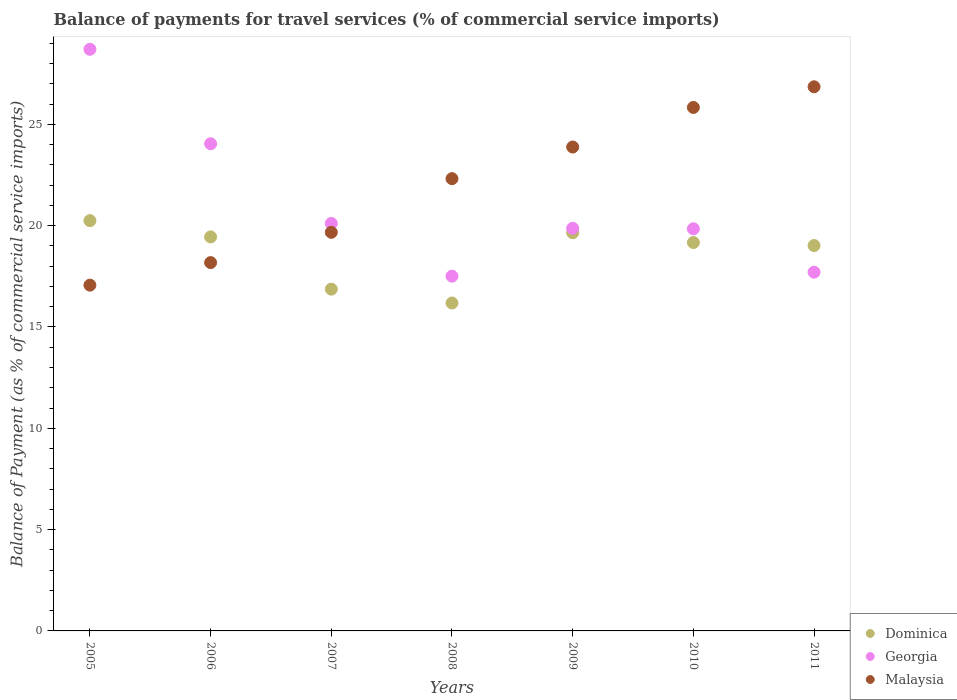What is the balance of payments for travel services in Georgia in 2007?
Provide a short and direct response. 20.11. Across all years, what is the maximum balance of payments for travel services in Georgia?
Make the answer very short. 28.7. Across all years, what is the minimum balance of payments for travel services in Malaysia?
Give a very brief answer. 17.06. What is the total balance of payments for travel services in Dominica in the graph?
Your answer should be compact. 130.57. What is the difference between the balance of payments for travel services in Malaysia in 2006 and that in 2008?
Provide a succinct answer. -4.14. What is the difference between the balance of payments for travel services in Malaysia in 2011 and the balance of payments for travel services in Dominica in 2010?
Ensure brevity in your answer.  7.69. What is the average balance of payments for travel services in Malaysia per year?
Your answer should be very brief. 21.97. In the year 2009, what is the difference between the balance of payments for travel services in Dominica and balance of payments for travel services in Malaysia?
Provide a succinct answer. -4.23. In how many years, is the balance of payments for travel services in Malaysia greater than 5 %?
Offer a very short reply. 7. What is the ratio of the balance of payments for travel services in Malaysia in 2006 to that in 2011?
Ensure brevity in your answer.  0.68. What is the difference between the highest and the second highest balance of payments for travel services in Malaysia?
Offer a terse response. 1.02. What is the difference between the highest and the lowest balance of payments for travel services in Malaysia?
Your answer should be compact. 9.79. In how many years, is the balance of payments for travel services in Malaysia greater than the average balance of payments for travel services in Malaysia taken over all years?
Your response must be concise. 4. Is it the case that in every year, the sum of the balance of payments for travel services in Dominica and balance of payments for travel services in Malaysia  is greater than the balance of payments for travel services in Georgia?
Your answer should be compact. Yes. Is the balance of payments for travel services in Georgia strictly greater than the balance of payments for travel services in Dominica over the years?
Provide a succinct answer. No. What is the difference between two consecutive major ticks on the Y-axis?
Ensure brevity in your answer.  5. Does the graph contain any zero values?
Make the answer very short. No. How many legend labels are there?
Offer a very short reply. 3. What is the title of the graph?
Give a very brief answer. Balance of payments for travel services (% of commercial service imports). Does "Jamaica" appear as one of the legend labels in the graph?
Give a very brief answer. No. What is the label or title of the X-axis?
Keep it short and to the point. Years. What is the label or title of the Y-axis?
Keep it short and to the point. Balance of Payment (as % of commercial service imports). What is the Balance of Payment (as % of commercial service imports) of Dominica in 2005?
Offer a very short reply. 20.25. What is the Balance of Payment (as % of commercial service imports) of Georgia in 2005?
Give a very brief answer. 28.7. What is the Balance of Payment (as % of commercial service imports) of Malaysia in 2005?
Your answer should be compact. 17.06. What is the Balance of Payment (as % of commercial service imports) in Dominica in 2006?
Offer a very short reply. 19.44. What is the Balance of Payment (as % of commercial service imports) of Georgia in 2006?
Give a very brief answer. 24.04. What is the Balance of Payment (as % of commercial service imports) in Malaysia in 2006?
Your answer should be very brief. 18.18. What is the Balance of Payment (as % of commercial service imports) of Dominica in 2007?
Give a very brief answer. 16.87. What is the Balance of Payment (as % of commercial service imports) of Georgia in 2007?
Make the answer very short. 20.11. What is the Balance of Payment (as % of commercial service imports) in Malaysia in 2007?
Your answer should be very brief. 19.67. What is the Balance of Payment (as % of commercial service imports) in Dominica in 2008?
Offer a very short reply. 16.18. What is the Balance of Payment (as % of commercial service imports) in Georgia in 2008?
Offer a terse response. 17.51. What is the Balance of Payment (as % of commercial service imports) in Malaysia in 2008?
Offer a very short reply. 22.32. What is the Balance of Payment (as % of commercial service imports) of Dominica in 2009?
Your answer should be compact. 19.65. What is the Balance of Payment (as % of commercial service imports) in Georgia in 2009?
Your answer should be very brief. 19.87. What is the Balance of Payment (as % of commercial service imports) of Malaysia in 2009?
Give a very brief answer. 23.88. What is the Balance of Payment (as % of commercial service imports) in Dominica in 2010?
Provide a succinct answer. 19.17. What is the Balance of Payment (as % of commercial service imports) in Georgia in 2010?
Ensure brevity in your answer.  19.84. What is the Balance of Payment (as % of commercial service imports) of Malaysia in 2010?
Offer a very short reply. 25.83. What is the Balance of Payment (as % of commercial service imports) in Dominica in 2011?
Your response must be concise. 19.02. What is the Balance of Payment (as % of commercial service imports) of Georgia in 2011?
Your answer should be very brief. 17.7. What is the Balance of Payment (as % of commercial service imports) in Malaysia in 2011?
Offer a very short reply. 26.85. Across all years, what is the maximum Balance of Payment (as % of commercial service imports) of Dominica?
Your answer should be compact. 20.25. Across all years, what is the maximum Balance of Payment (as % of commercial service imports) of Georgia?
Provide a succinct answer. 28.7. Across all years, what is the maximum Balance of Payment (as % of commercial service imports) of Malaysia?
Keep it short and to the point. 26.85. Across all years, what is the minimum Balance of Payment (as % of commercial service imports) of Dominica?
Provide a succinct answer. 16.18. Across all years, what is the minimum Balance of Payment (as % of commercial service imports) of Georgia?
Offer a terse response. 17.51. Across all years, what is the minimum Balance of Payment (as % of commercial service imports) of Malaysia?
Provide a succinct answer. 17.06. What is the total Balance of Payment (as % of commercial service imports) of Dominica in the graph?
Your response must be concise. 130.57. What is the total Balance of Payment (as % of commercial service imports) in Georgia in the graph?
Make the answer very short. 147.77. What is the total Balance of Payment (as % of commercial service imports) of Malaysia in the graph?
Make the answer very short. 153.79. What is the difference between the Balance of Payment (as % of commercial service imports) of Dominica in 2005 and that in 2006?
Your answer should be compact. 0.8. What is the difference between the Balance of Payment (as % of commercial service imports) of Georgia in 2005 and that in 2006?
Your answer should be compact. 4.66. What is the difference between the Balance of Payment (as % of commercial service imports) in Malaysia in 2005 and that in 2006?
Make the answer very short. -1.11. What is the difference between the Balance of Payment (as % of commercial service imports) in Dominica in 2005 and that in 2007?
Your answer should be compact. 3.38. What is the difference between the Balance of Payment (as % of commercial service imports) in Georgia in 2005 and that in 2007?
Offer a terse response. 8.59. What is the difference between the Balance of Payment (as % of commercial service imports) of Malaysia in 2005 and that in 2007?
Make the answer very short. -2.61. What is the difference between the Balance of Payment (as % of commercial service imports) of Dominica in 2005 and that in 2008?
Give a very brief answer. 4.07. What is the difference between the Balance of Payment (as % of commercial service imports) of Georgia in 2005 and that in 2008?
Offer a terse response. 11.2. What is the difference between the Balance of Payment (as % of commercial service imports) of Malaysia in 2005 and that in 2008?
Ensure brevity in your answer.  -5.25. What is the difference between the Balance of Payment (as % of commercial service imports) in Dominica in 2005 and that in 2009?
Keep it short and to the point. 0.6. What is the difference between the Balance of Payment (as % of commercial service imports) of Georgia in 2005 and that in 2009?
Give a very brief answer. 8.84. What is the difference between the Balance of Payment (as % of commercial service imports) of Malaysia in 2005 and that in 2009?
Keep it short and to the point. -6.82. What is the difference between the Balance of Payment (as % of commercial service imports) in Dominica in 2005 and that in 2010?
Your response must be concise. 1.08. What is the difference between the Balance of Payment (as % of commercial service imports) in Georgia in 2005 and that in 2010?
Keep it short and to the point. 8.86. What is the difference between the Balance of Payment (as % of commercial service imports) of Malaysia in 2005 and that in 2010?
Offer a very short reply. -8.77. What is the difference between the Balance of Payment (as % of commercial service imports) of Dominica in 2005 and that in 2011?
Make the answer very short. 1.23. What is the difference between the Balance of Payment (as % of commercial service imports) in Georgia in 2005 and that in 2011?
Make the answer very short. 11. What is the difference between the Balance of Payment (as % of commercial service imports) in Malaysia in 2005 and that in 2011?
Your answer should be very brief. -9.79. What is the difference between the Balance of Payment (as % of commercial service imports) of Dominica in 2006 and that in 2007?
Offer a very short reply. 2.58. What is the difference between the Balance of Payment (as % of commercial service imports) of Georgia in 2006 and that in 2007?
Offer a very short reply. 3.93. What is the difference between the Balance of Payment (as % of commercial service imports) in Malaysia in 2006 and that in 2007?
Ensure brevity in your answer.  -1.49. What is the difference between the Balance of Payment (as % of commercial service imports) in Dominica in 2006 and that in 2008?
Offer a terse response. 3.26. What is the difference between the Balance of Payment (as % of commercial service imports) in Georgia in 2006 and that in 2008?
Provide a succinct answer. 6.53. What is the difference between the Balance of Payment (as % of commercial service imports) in Malaysia in 2006 and that in 2008?
Give a very brief answer. -4.14. What is the difference between the Balance of Payment (as % of commercial service imports) in Dominica in 2006 and that in 2009?
Your answer should be compact. -0.21. What is the difference between the Balance of Payment (as % of commercial service imports) of Georgia in 2006 and that in 2009?
Provide a succinct answer. 4.17. What is the difference between the Balance of Payment (as % of commercial service imports) of Malaysia in 2006 and that in 2009?
Make the answer very short. -5.7. What is the difference between the Balance of Payment (as % of commercial service imports) of Dominica in 2006 and that in 2010?
Offer a very short reply. 0.28. What is the difference between the Balance of Payment (as % of commercial service imports) of Georgia in 2006 and that in 2010?
Provide a short and direct response. 4.2. What is the difference between the Balance of Payment (as % of commercial service imports) of Malaysia in 2006 and that in 2010?
Make the answer very short. -7.66. What is the difference between the Balance of Payment (as % of commercial service imports) in Dominica in 2006 and that in 2011?
Offer a terse response. 0.43. What is the difference between the Balance of Payment (as % of commercial service imports) of Georgia in 2006 and that in 2011?
Make the answer very short. 6.34. What is the difference between the Balance of Payment (as % of commercial service imports) in Malaysia in 2006 and that in 2011?
Make the answer very short. -8.68. What is the difference between the Balance of Payment (as % of commercial service imports) of Dominica in 2007 and that in 2008?
Give a very brief answer. 0.69. What is the difference between the Balance of Payment (as % of commercial service imports) of Georgia in 2007 and that in 2008?
Your response must be concise. 2.6. What is the difference between the Balance of Payment (as % of commercial service imports) in Malaysia in 2007 and that in 2008?
Your answer should be compact. -2.65. What is the difference between the Balance of Payment (as % of commercial service imports) of Dominica in 2007 and that in 2009?
Keep it short and to the point. -2.78. What is the difference between the Balance of Payment (as % of commercial service imports) in Georgia in 2007 and that in 2009?
Ensure brevity in your answer.  0.24. What is the difference between the Balance of Payment (as % of commercial service imports) of Malaysia in 2007 and that in 2009?
Your response must be concise. -4.21. What is the difference between the Balance of Payment (as % of commercial service imports) of Dominica in 2007 and that in 2010?
Your answer should be compact. -2.3. What is the difference between the Balance of Payment (as % of commercial service imports) of Georgia in 2007 and that in 2010?
Your answer should be compact. 0.27. What is the difference between the Balance of Payment (as % of commercial service imports) of Malaysia in 2007 and that in 2010?
Keep it short and to the point. -6.16. What is the difference between the Balance of Payment (as % of commercial service imports) in Dominica in 2007 and that in 2011?
Keep it short and to the point. -2.15. What is the difference between the Balance of Payment (as % of commercial service imports) of Georgia in 2007 and that in 2011?
Offer a very short reply. 2.41. What is the difference between the Balance of Payment (as % of commercial service imports) in Malaysia in 2007 and that in 2011?
Give a very brief answer. -7.18. What is the difference between the Balance of Payment (as % of commercial service imports) in Dominica in 2008 and that in 2009?
Give a very brief answer. -3.47. What is the difference between the Balance of Payment (as % of commercial service imports) in Georgia in 2008 and that in 2009?
Provide a succinct answer. -2.36. What is the difference between the Balance of Payment (as % of commercial service imports) in Malaysia in 2008 and that in 2009?
Your response must be concise. -1.56. What is the difference between the Balance of Payment (as % of commercial service imports) in Dominica in 2008 and that in 2010?
Your answer should be very brief. -2.99. What is the difference between the Balance of Payment (as % of commercial service imports) in Georgia in 2008 and that in 2010?
Offer a terse response. -2.34. What is the difference between the Balance of Payment (as % of commercial service imports) in Malaysia in 2008 and that in 2010?
Give a very brief answer. -3.51. What is the difference between the Balance of Payment (as % of commercial service imports) in Dominica in 2008 and that in 2011?
Your response must be concise. -2.84. What is the difference between the Balance of Payment (as % of commercial service imports) in Georgia in 2008 and that in 2011?
Offer a very short reply. -0.2. What is the difference between the Balance of Payment (as % of commercial service imports) in Malaysia in 2008 and that in 2011?
Your response must be concise. -4.53. What is the difference between the Balance of Payment (as % of commercial service imports) of Dominica in 2009 and that in 2010?
Offer a terse response. 0.48. What is the difference between the Balance of Payment (as % of commercial service imports) in Georgia in 2009 and that in 2010?
Provide a succinct answer. 0.02. What is the difference between the Balance of Payment (as % of commercial service imports) in Malaysia in 2009 and that in 2010?
Offer a very short reply. -1.95. What is the difference between the Balance of Payment (as % of commercial service imports) of Dominica in 2009 and that in 2011?
Offer a terse response. 0.63. What is the difference between the Balance of Payment (as % of commercial service imports) in Georgia in 2009 and that in 2011?
Your answer should be compact. 2.16. What is the difference between the Balance of Payment (as % of commercial service imports) of Malaysia in 2009 and that in 2011?
Keep it short and to the point. -2.97. What is the difference between the Balance of Payment (as % of commercial service imports) of Dominica in 2010 and that in 2011?
Provide a succinct answer. 0.15. What is the difference between the Balance of Payment (as % of commercial service imports) in Georgia in 2010 and that in 2011?
Provide a short and direct response. 2.14. What is the difference between the Balance of Payment (as % of commercial service imports) in Malaysia in 2010 and that in 2011?
Provide a succinct answer. -1.02. What is the difference between the Balance of Payment (as % of commercial service imports) of Dominica in 2005 and the Balance of Payment (as % of commercial service imports) of Georgia in 2006?
Offer a very short reply. -3.79. What is the difference between the Balance of Payment (as % of commercial service imports) of Dominica in 2005 and the Balance of Payment (as % of commercial service imports) of Malaysia in 2006?
Keep it short and to the point. 2.07. What is the difference between the Balance of Payment (as % of commercial service imports) in Georgia in 2005 and the Balance of Payment (as % of commercial service imports) in Malaysia in 2006?
Make the answer very short. 10.53. What is the difference between the Balance of Payment (as % of commercial service imports) in Dominica in 2005 and the Balance of Payment (as % of commercial service imports) in Georgia in 2007?
Provide a short and direct response. 0.14. What is the difference between the Balance of Payment (as % of commercial service imports) of Dominica in 2005 and the Balance of Payment (as % of commercial service imports) of Malaysia in 2007?
Your answer should be very brief. 0.58. What is the difference between the Balance of Payment (as % of commercial service imports) of Georgia in 2005 and the Balance of Payment (as % of commercial service imports) of Malaysia in 2007?
Make the answer very short. 9.03. What is the difference between the Balance of Payment (as % of commercial service imports) of Dominica in 2005 and the Balance of Payment (as % of commercial service imports) of Georgia in 2008?
Provide a short and direct response. 2.74. What is the difference between the Balance of Payment (as % of commercial service imports) in Dominica in 2005 and the Balance of Payment (as % of commercial service imports) in Malaysia in 2008?
Keep it short and to the point. -2.07. What is the difference between the Balance of Payment (as % of commercial service imports) of Georgia in 2005 and the Balance of Payment (as % of commercial service imports) of Malaysia in 2008?
Give a very brief answer. 6.38. What is the difference between the Balance of Payment (as % of commercial service imports) of Dominica in 2005 and the Balance of Payment (as % of commercial service imports) of Georgia in 2009?
Offer a very short reply. 0.38. What is the difference between the Balance of Payment (as % of commercial service imports) of Dominica in 2005 and the Balance of Payment (as % of commercial service imports) of Malaysia in 2009?
Make the answer very short. -3.63. What is the difference between the Balance of Payment (as % of commercial service imports) in Georgia in 2005 and the Balance of Payment (as % of commercial service imports) in Malaysia in 2009?
Your answer should be compact. 4.82. What is the difference between the Balance of Payment (as % of commercial service imports) of Dominica in 2005 and the Balance of Payment (as % of commercial service imports) of Georgia in 2010?
Your answer should be very brief. 0.4. What is the difference between the Balance of Payment (as % of commercial service imports) in Dominica in 2005 and the Balance of Payment (as % of commercial service imports) in Malaysia in 2010?
Your answer should be compact. -5.59. What is the difference between the Balance of Payment (as % of commercial service imports) of Georgia in 2005 and the Balance of Payment (as % of commercial service imports) of Malaysia in 2010?
Your answer should be compact. 2.87. What is the difference between the Balance of Payment (as % of commercial service imports) of Dominica in 2005 and the Balance of Payment (as % of commercial service imports) of Georgia in 2011?
Offer a very short reply. 2.54. What is the difference between the Balance of Payment (as % of commercial service imports) of Dominica in 2005 and the Balance of Payment (as % of commercial service imports) of Malaysia in 2011?
Offer a terse response. -6.61. What is the difference between the Balance of Payment (as % of commercial service imports) in Georgia in 2005 and the Balance of Payment (as % of commercial service imports) in Malaysia in 2011?
Your answer should be very brief. 1.85. What is the difference between the Balance of Payment (as % of commercial service imports) in Dominica in 2006 and the Balance of Payment (as % of commercial service imports) in Georgia in 2007?
Ensure brevity in your answer.  -0.66. What is the difference between the Balance of Payment (as % of commercial service imports) in Dominica in 2006 and the Balance of Payment (as % of commercial service imports) in Malaysia in 2007?
Give a very brief answer. -0.23. What is the difference between the Balance of Payment (as % of commercial service imports) of Georgia in 2006 and the Balance of Payment (as % of commercial service imports) of Malaysia in 2007?
Make the answer very short. 4.37. What is the difference between the Balance of Payment (as % of commercial service imports) in Dominica in 2006 and the Balance of Payment (as % of commercial service imports) in Georgia in 2008?
Your response must be concise. 1.94. What is the difference between the Balance of Payment (as % of commercial service imports) in Dominica in 2006 and the Balance of Payment (as % of commercial service imports) in Malaysia in 2008?
Your answer should be very brief. -2.87. What is the difference between the Balance of Payment (as % of commercial service imports) in Georgia in 2006 and the Balance of Payment (as % of commercial service imports) in Malaysia in 2008?
Provide a short and direct response. 1.72. What is the difference between the Balance of Payment (as % of commercial service imports) of Dominica in 2006 and the Balance of Payment (as % of commercial service imports) of Georgia in 2009?
Give a very brief answer. -0.42. What is the difference between the Balance of Payment (as % of commercial service imports) in Dominica in 2006 and the Balance of Payment (as % of commercial service imports) in Malaysia in 2009?
Your answer should be very brief. -4.43. What is the difference between the Balance of Payment (as % of commercial service imports) in Georgia in 2006 and the Balance of Payment (as % of commercial service imports) in Malaysia in 2009?
Provide a short and direct response. 0.16. What is the difference between the Balance of Payment (as % of commercial service imports) in Dominica in 2006 and the Balance of Payment (as % of commercial service imports) in Georgia in 2010?
Your answer should be compact. -0.4. What is the difference between the Balance of Payment (as % of commercial service imports) in Dominica in 2006 and the Balance of Payment (as % of commercial service imports) in Malaysia in 2010?
Your response must be concise. -6.39. What is the difference between the Balance of Payment (as % of commercial service imports) of Georgia in 2006 and the Balance of Payment (as % of commercial service imports) of Malaysia in 2010?
Your answer should be compact. -1.79. What is the difference between the Balance of Payment (as % of commercial service imports) of Dominica in 2006 and the Balance of Payment (as % of commercial service imports) of Georgia in 2011?
Give a very brief answer. 1.74. What is the difference between the Balance of Payment (as % of commercial service imports) of Dominica in 2006 and the Balance of Payment (as % of commercial service imports) of Malaysia in 2011?
Provide a succinct answer. -7.41. What is the difference between the Balance of Payment (as % of commercial service imports) of Georgia in 2006 and the Balance of Payment (as % of commercial service imports) of Malaysia in 2011?
Make the answer very short. -2.81. What is the difference between the Balance of Payment (as % of commercial service imports) in Dominica in 2007 and the Balance of Payment (as % of commercial service imports) in Georgia in 2008?
Provide a succinct answer. -0.64. What is the difference between the Balance of Payment (as % of commercial service imports) of Dominica in 2007 and the Balance of Payment (as % of commercial service imports) of Malaysia in 2008?
Provide a short and direct response. -5.45. What is the difference between the Balance of Payment (as % of commercial service imports) in Georgia in 2007 and the Balance of Payment (as % of commercial service imports) in Malaysia in 2008?
Give a very brief answer. -2.21. What is the difference between the Balance of Payment (as % of commercial service imports) in Dominica in 2007 and the Balance of Payment (as % of commercial service imports) in Georgia in 2009?
Provide a succinct answer. -3. What is the difference between the Balance of Payment (as % of commercial service imports) in Dominica in 2007 and the Balance of Payment (as % of commercial service imports) in Malaysia in 2009?
Offer a very short reply. -7.01. What is the difference between the Balance of Payment (as % of commercial service imports) of Georgia in 2007 and the Balance of Payment (as % of commercial service imports) of Malaysia in 2009?
Your response must be concise. -3.77. What is the difference between the Balance of Payment (as % of commercial service imports) in Dominica in 2007 and the Balance of Payment (as % of commercial service imports) in Georgia in 2010?
Offer a terse response. -2.98. What is the difference between the Balance of Payment (as % of commercial service imports) in Dominica in 2007 and the Balance of Payment (as % of commercial service imports) in Malaysia in 2010?
Keep it short and to the point. -8.97. What is the difference between the Balance of Payment (as % of commercial service imports) in Georgia in 2007 and the Balance of Payment (as % of commercial service imports) in Malaysia in 2010?
Provide a succinct answer. -5.72. What is the difference between the Balance of Payment (as % of commercial service imports) in Dominica in 2007 and the Balance of Payment (as % of commercial service imports) in Georgia in 2011?
Keep it short and to the point. -0.84. What is the difference between the Balance of Payment (as % of commercial service imports) in Dominica in 2007 and the Balance of Payment (as % of commercial service imports) in Malaysia in 2011?
Make the answer very short. -9.99. What is the difference between the Balance of Payment (as % of commercial service imports) of Georgia in 2007 and the Balance of Payment (as % of commercial service imports) of Malaysia in 2011?
Your response must be concise. -6.74. What is the difference between the Balance of Payment (as % of commercial service imports) of Dominica in 2008 and the Balance of Payment (as % of commercial service imports) of Georgia in 2009?
Offer a terse response. -3.69. What is the difference between the Balance of Payment (as % of commercial service imports) in Dominica in 2008 and the Balance of Payment (as % of commercial service imports) in Malaysia in 2009?
Ensure brevity in your answer.  -7.7. What is the difference between the Balance of Payment (as % of commercial service imports) of Georgia in 2008 and the Balance of Payment (as % of commercial service imports) of Malaysia in 2009?
Keep it short and to the point. -6.37. What is the difference between the Balance of Payment (as % of commercial service imports) in Dominica in 2008 and the Balance of Payment (as % of commercial service imports) in Georgia in 2010?
Provide a short and direct response. -3.66. What is the difference between the Balance of Payment (as % of commercial service imports) in Dominica in 2008 and the Balance of Payment (as % of commercial service imports) in Malaysia in 2010?
Ensure brevity in your answer.  -9.65. What is the difference between the Balance of Payment (as % of commercial service imports) in Georgia in 2008 and the Balance of Payment (as % of commercial service imports) in Malaysia in 2010?
Give a very brief answer. -8.32. What is the difference between the Balance of Payment (as % of commercial service imports) of Dominica in 2008 and the Balance of Payment (as % of commercial service imports) of Georgia in 2011?
Make the answer very short. -1.52. What is the difference between the Balance of Payment (as % of commercial service imports) of Dominica in 2008 and the Balance of Payment (as % of commercial service imports) of Malaysia in 2011?
Keep it short and to the point. -10.67. What is the difference between the Balance of Payment (as % of commercial service imports) of Georgia in 2008 and the Balance of Payment (as % of commercial service imports) of Malaysia in 2011?
Your response must be concise. -9.34. What is the difference between the Balance of Payment (as % of commercial service imports) of Dominica in 2009 and the Balance of Payment (as % of commercial service imports) of Georgia in 2010?
Offer a terse response. -0.19. What is the difference between the Balance of Payment (as % of commercial service imports) in Dominica in 2009 and the Balance of Payment (as % of commercial service imports) in Malaysia in 2010?
Make the answer very short. -6.18. What is the difference between the Balance of Payment (as % of commercial service imports) in Georgia in 2009 and the Balance of Payment (as % of commercial service imports) in Malaysia in 2010?
Provide a short and direct response. -5.96. What is the difference between the Balance of Payment (as % of commercial service imports) in Dominica in 2009 and the Balance of Payment (as % of commercial service imports) in Georgia in 2011?
Your answer should be very brief. 1.95. What is the difference between the Balance of Payment (as % of commercial service imports) of Dominica in 2009 and the Balance of Payment (as % of commercial service imports) of Malaysia in 2011?
Give a very brief answer. -7.2. What is the difference between the Balance of Payment (as % of commercial service imports) in Georgia in 2009 and the Balance of Payment (as % of commercial service imports) in Malaysia in 2011?
Your response must be concise. -6.98. What is the difference between the Balance of Payment (as % of commercial service imports) in Dominica in 2010 and the Balance of Payment (as % of commercial service imports) in Georgia in 2011?
Offer a terse response. 1.46. What is the difference between the Balance of Payment (as % of commercial service imports) in Dominica in 2010 and the Balance of Payment (as % of commercial service imports) in Malaysia in 2011?
Offer a terse response. -7.69. What is the difference between the Balance of Payment (as % of commercial service imports) of Georgia in 2010 and the Balance of Payment (as % of commercial service imports) of Malaysia in 2011?
Give a very brief answer. -7.01. What is the average Balance of Payment (as % of commercial service imports) in Dominica per year?
Ensure brevity in your answer.  18.65. What is the average Balance of Payment (as % of commercial service imports) of Georgia per year?
Provide a short and direct response. 21.11. What is the average Balance of Payment (as % of commercial service imports) of Malaysia per year?
Provide a succinct answer. 21.97. In the year 2005, what is the difference between the Balance of Payment (as % of commercial service imports) in Dominica and Balance of Payment (as % of commercial service imports) in Georgia?
Your answer should be very brief. -8.46. In the year 2005, what is the difference between the Balance of Payment (as % of commercial service imports) of Dominica and Balance of Payment (as % of commercial service imports) of Malaysia?
Give a very brief answer. 3.18. In the year 2005, what is the difference between the Balance of Payment (as % of commercial service imports) in Georgia and Balance of Payment (as % of commercial service imports) in Malaysia?
Offer a very short reply. 11.64. In the year 2006, what is the difference between the Balance of Payment (as % of commercial service imports) in Dominica and Balance of Payment (as % of commercial service imports) in Georgia?
Offer a terse response. -4.6. In the year 2006, what is the difference between the Balance of Payment (as % of commercial service imports) in Dominica and Balance of Payment (as % of commercial service imports) in Malaysia?
Your answer should be very brief. 1.27. In the year 2006, what is the difference between the Balance of Payment (as % of commercial service imports) of Georgia and Balance of Payment (as % of commercial service imports) of Malaysia?
Your response must be concise. 5.86. In the year 2007, what is the difference between the Balance of Payment (as % of commercial service imports) of Dominica and Balance of Payment (as % of commercial service imports) of Georgia?
Provide a short and direct response. -3.24. In the year 2007, what is the difference between the Balance of Payment (as % of commercial service imports) of Dominica and Balance of Payment (as % of commercial service imports) of Malaysia?
Ensure brevity in your answer.  -2.8. In the year 2007, what is the difference between the Balance of Payment (as % of commercial service imports) of Georgia and Balance of Payment (as % of commercial service imports) of Malaysia?
Offer a very short reply. 0.44. In the year 2008, what is the difference between the Balance of Payment (as % of commercial service imports) in Dominica and Balance of Payment (as % of commercial service imports) in Georgia?
Offer a very short reply. -1.33. In the year 2008, what is the difference between the Balance of Payment (as % of commercial service imports) of Dominica and Balance of Payment (as % of commercial service imports) of Malaysia?
Offer a very short reply. -6.14. In the year 2008, what is the difference between the Balance of Payment (as % of commercial service imports) in Georgia and Balance of Payment (as % of commercial service imports) in Malaysia?
Your answer should be compact. -4.81. In the year 2009, what is the difference between the Balance of Payment (as % of commercial service imports) of Dominica and Balance of Payment (as % of commercial service imports) of Georgia?
Give a very brief answer. -0.22. In the year 2009, what is the difference between the Balance of Payment (as % of commercial service imports) of Dominica and Balance of Payment (as % of commercial service imports) of Malaysia?
Offer a very short reply. -4.23. In the year 2009, what is the difference between the Balance of Payment (as % of commercial service imports) in Georgia and Balance of Payment (as % of commercial service imports) in Malaysia?
Offer a very short reply. -4.01. In the year 2010, what is the difference between the Balance of Payment (as % of commercial service imports) of Dominica and Balance of Payment (as % of commercial service imports) of Georgia?
Offer a terse response. -0.68. In the year 2010, what is the difference between the Balance of Payment (as % of commercial service imports) in Dominica and Balance of Payment (as % of commercial service imports) in Malaysia?
Offer a terse response. -6.67. In the year 2010, what is the difference between the Balance of Payment (as % of commercial service imports) in Georgia and Balance of Payment (as % of commercial service imports) in Malaysia?
Ensure brevity in your answer.  -5.99. In the year 2011, what is the difference between the Balance of Payment (as % of commercial service imports) in Dominica and Balance of Payment (as % of commercial service imports) in Georgia?
Keep it short and to the point. 1.31. In the year 2011, what is the difference between the Balance of Payment (as % of commercial service imports) in Dominica and Balance of Payment (as % of commercial service imports) in Malaysia?
Offer a very short reply. -7.83. In the year 2011, what is the difference between the Balance of Payment (as % of commercial service imports) of Georgia and Balance of Payment (as % of commercial service imports) of Malaysia?
Keep it short and to the point. -9.15. What is the ratio of the Balance of Payment (as % of commercial service imports) in Dominica in 2005 to that in 2006?
Keep it short and to the point. 1.04. What is the ratio of the Balance of Payment (as % of commercial service imports) in Georgia in 2005 to that in 2006?
Your answer should be very brief. 1.19. What is the ratio of the Balance of Payment (as % of commercial service imports) in Malaysia in 2005 to that in 2006?
Keep it short and to the point. 0.94. What is the ratio of the Balance of Payment (as % of commercial service imports) in Dominica in 2005 to that in 2007?
Keep it short and to the point. 1.2. What is the ratio of the Balance of Payment (as % of commercial service imports) in Georgia in 2005 to that in 2007?
Provide a succinct answer. 1.43. What is the ratio of the Balance of Payment (as % of commercial service imports) of Malaysia in 2005 to that in 2007?
Your answer should be very brief. 0.87. What is the ratio of the Balance of Payment (as % of commercial service imports) in Dominica in 2005 to that in 2008?
Provide a succinct answer. 1.25. What is the ratio of the Balance of Payment (as % of commercial service imports) of Georgia in 2005 to that in 2008?
Your answer should be compact. 1.64. What is the ratio of the Balance of Payment (as % of commercial service imports) of Malaysia in 2005 to that in 2008?
Offer a very short reply. 0.76. What is the ratio of the Balance of Payment (as % of commercial service imports) of Dominica in 2005 to that in 2009?
Your response must be concise. 1.03. What is the ratio of the Balance of Payment (as % of commercial service imports) of Georgia in 2005 to that in 2009?
Your response must be concise. 1.44. What is the ratio of the Balance of Payment (as % of commercial service imports) in Malaysia in 2005 to that in 2009?
Your answer should be very brief. 0.71. What is the ratio of the Balance of Payment (as % of commercial service imports) of Dominica in 2005 to that in 2010?
Give a very brief answer. 1.06. What is the ratio of the Balance of Payment (as % of commercial service imports) of Georgia in 2005 to that in 2010?
Provide a short and direct response. 1.45. What is the ratio of the Balance of Payment (as % of commercial service imports) of Malaysia in 2005 to that in 2010?
Offer a terse response. 0.66. What is the ratio of the Balance of Payment (as % of commercial service imports) of Dominica in 2005 to that in 2011?
Make the answer very short. 1.06. What is the ratio of the Balance of Payment (as % of commercial service imports) of Georgia in 2005 to that in 2011?
Make the answer very short. 1.62. What is the ratio of the Balance of Payment (as % of commercial service imports) in Malaysia in 2005 to that in 2011?
Your answer should be very brief. 0.64. What is the ratio of the Balance of Payment (as % of commercial service imports) in Dominica in 2006 to that in 2007?
Your answer should be very brief. 1.15. What is the ratio of the Balance of Payment (as % of commercial service imports) in Georgia in 2006 to that in 2007?
Your answer should be very brief. 1.2. What is the ratio of the Balance of Payment (as % of commercial service imports) in Malaysia in 2006 to that in 2007?
Your answer should be very brief. 0.92. What is the ratio of the Balance of Payment (as % of commercial service imports) of Dominica in 2006 to that in 2008?
Offer a very short reply. 1.2. What is the ratio of the Balance of Payment (as % of commercial service imports) in Georgia in 2006 to that in 2008?
Provide a short and direct response. 1.37. What is the ratio of the Balance of Payment (as % of commercial service imports) of Malaysia in 2006 to that in 2008?
Your answer should be compact. 0.81. What is the ratio of the Balance of Payment (as % of commercial service imports) of Dominica in 2006 to that in 2009?
Your answer should be very brief. 0.99. What is the ratio of the Balance of Payment (as % of commercial service imports) in Georgia in 2006 to that in 2009?
Provide a succinct answer. 1.21. What is the ratio of the Balance of Payment (as % of commercial service imports) in Malaysia in 2006 to that in 2009?
Give a very brief answer. 0.76. What is the ratio of the Balance of Payment (as % of commercial service imports) of Dominica in 2006 to that in 2010?
Make the answer very short. 1.01. What is the ratio of the Balance of Payment (as % of commercial service imports) in Georgia in 2006 to that in 2010?
Your response must be concise. 1.21. What is the ratio of the Balance of Payment (as % of commercial service imports) of Malaysia in 2006 to that in 2010?
Offer a terse response. 0.7. What is the ratio of the Balance of Payment (as % of commercial service imports) in Dominica in 2006 to that in 2011?
Provide a succinct answer. 1.02. What is the ratio of the Balance of Payment (as % of commercial service imports) of Georgia in 2006 to that in 2011?
Provide a succinct answer. 1.36. What is the ratio of the Balance of Payment (as % of commercial service imports) in Malaysia in 2006 to that in 2011?
Provide a short and direct response. 0.68. What is the ratio of the Balance of Payment (as % of commercial service imports) of Dominica in 2007 to that in 2008?
Keep it short and to the point. 1.04. What is the ratio of the Balance of Payment (as % of commercial service imports) of Georgia in 2007 to that in 2008?
Provide a succinct answer. 1.15. What is the ratio of the Balance of Payment (as % of commercial service imports) in Malaysia in 2007 to that in 2008?
Offer a terse response. 0.88. What is the ratio of the Balance of Payment (as % of commercial service imports) of Dominica in 2007 to that in 2009?
Your response must be concise. 0.86. What is the ratio of the Balance of Payment (as % of commercial service imports) of Georgia in 2007 to that in 2009?
Offer a very short reply. 1.01. What is the ratio of the Balance of Payment (as % of commercial service imports) of Malaysia in 2007 to that in 2009?
Ensure brevity in your answer.  0.82. What is the ratio of the Balance of Payment (as % of commercial service imports) in Georgia in 2007 to that in 2010?
Offer a very short reply. 1.01. What is the ratio of the Balance of Payment (as % of commercial service imports) in Malaysia in 2007 to that in 2010?
Make the answer very short. 0.76. What is the ratio of the Balance of Payment (as % of commercial service imports) of Dominica in 2007 to that in 2011?
Ensure brevity in your answer.  0.89. What is the ratio of the Balance of Payment (as % of commercial service imports) of Georgia in 2007 to that in 2011?
Offer a terse response. 1.14. What is the ratio of the Balance of Payment (as % of commercial service imports) in Malaysia in 2007 to that in 2011?
Offer a very short reply. 0.73. What is the ratio of the Balance of Payment (as % of commercial service imports) in Dominica in 2008 to that in 2009?
Keep it short and to the point. 0.82. What is the ratio of the Balance of Payment (as % of commercial service imports) of Georgia in 2008 to that in 2009?
Give a very brief answer. 0.88. What is the ratio of the Balance of Payment (as % of commercial service imports) of Malaysia in 2008 to that in 2009?
Give a very brief answer. 0.93. What is the ratio of the Balance of Payment (as % of commercial service imports) in Dominica in 2008 to that in 2010?
Provide a short and direct response. 0.84. What is the ratio of the Balance of Payment (as % of commercial service imports) in Georgia in 2008 to that in 2010?
Provide a succinct answer. 0.88. What is the ratio of the Balance of Payment (as % of commercial service imports) in Malaysia in 2008 to that in 2010?
Provide a short and direct response. 0.86. What is the ratio of the Balance of Payment (as % of commercial service imports) of Dominica in 2008 to that in 2011?
Keep it short and to the point. 0.85. What is the ratio of the Balance of Payment (as % of commercial service imports) of Georgia in 2008 to that in 2011?
Offer a very short reply. 0.99. What is the ratio of the Balance of Payment (as % of commercial service imports) in Malaysia in 2008 to that in 2011?
Keep it short and to the point. 0.83. What is the ratio of the Balance of Payment (as % of commercial service imports) of Dominica in 2009 to that in 2010?
Offer a terse response. 1.03. What is the ratio of the Balance of Payment (as % of commercial service imports) in Malaysia in 2009 to that in 2010?
Keep it short and to the point. 0.92. What is the ratio of the Balance of Payment (as % of commercial service imports) of Georgia in 2009 to that in 2011?
Your answer should be very brief. 1.12. What is the ratio of the Balance of Payment (as % of commercial service imports) of Malaysia in 2009 to that in 2011?
Your response must be concise. 0.89. What is the ratio of the Balance of Payment (as % of commercial service imports) in Dominica in 2010 to that in 2011?
Provide a short and direct response. 1.01. What is the ratio of the Balance of Payment (as % of commercial service imports) in Georgia in 2010 to that in 2011?
Offer a terse response. 1.12. What is the ratio of the Balance of Payment (as % of commercial service imports) of Malaysia in 2010 to that in 2011?
Provide a succinct answer. 0.96. What is the difference between the highest and the second highest Balance of Payment (as % of commercial service imports) in Dominica?
Provide a short and direct response. 0.6. What is the difference between the highest and the second highest Balance of Payment (as % of commercial service imports) of Georgia?
Keep it short and to the point. 4.66. What is the difference between the highest and the second highest Balance of Payment (as % of commercial service imports) in Malaysia?
Make the answer very short. 1.02. What is the difference between the highest and the lowest Balance of Payment (as % of commercial service imports) in Dominica?
Your answer should be very brief. 4.07. What is the difference between the highest and the lowest Balance of Payment (as % of commercial service imports) of Georgia?
Give a very brief answer. 11.2. What is the difference between the highest and the lowest Balance of Payment (as % of commercial service imports) in Malaysia?
Make the answer very short. 9.79. 